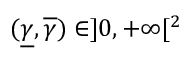<formula> <loc_0><loc_0><loc_500><loc_500>( \underline { \gamma } , \overline { \gamma } ) \in ] 0 , + \infty [ ^ { 2 }</formula> 